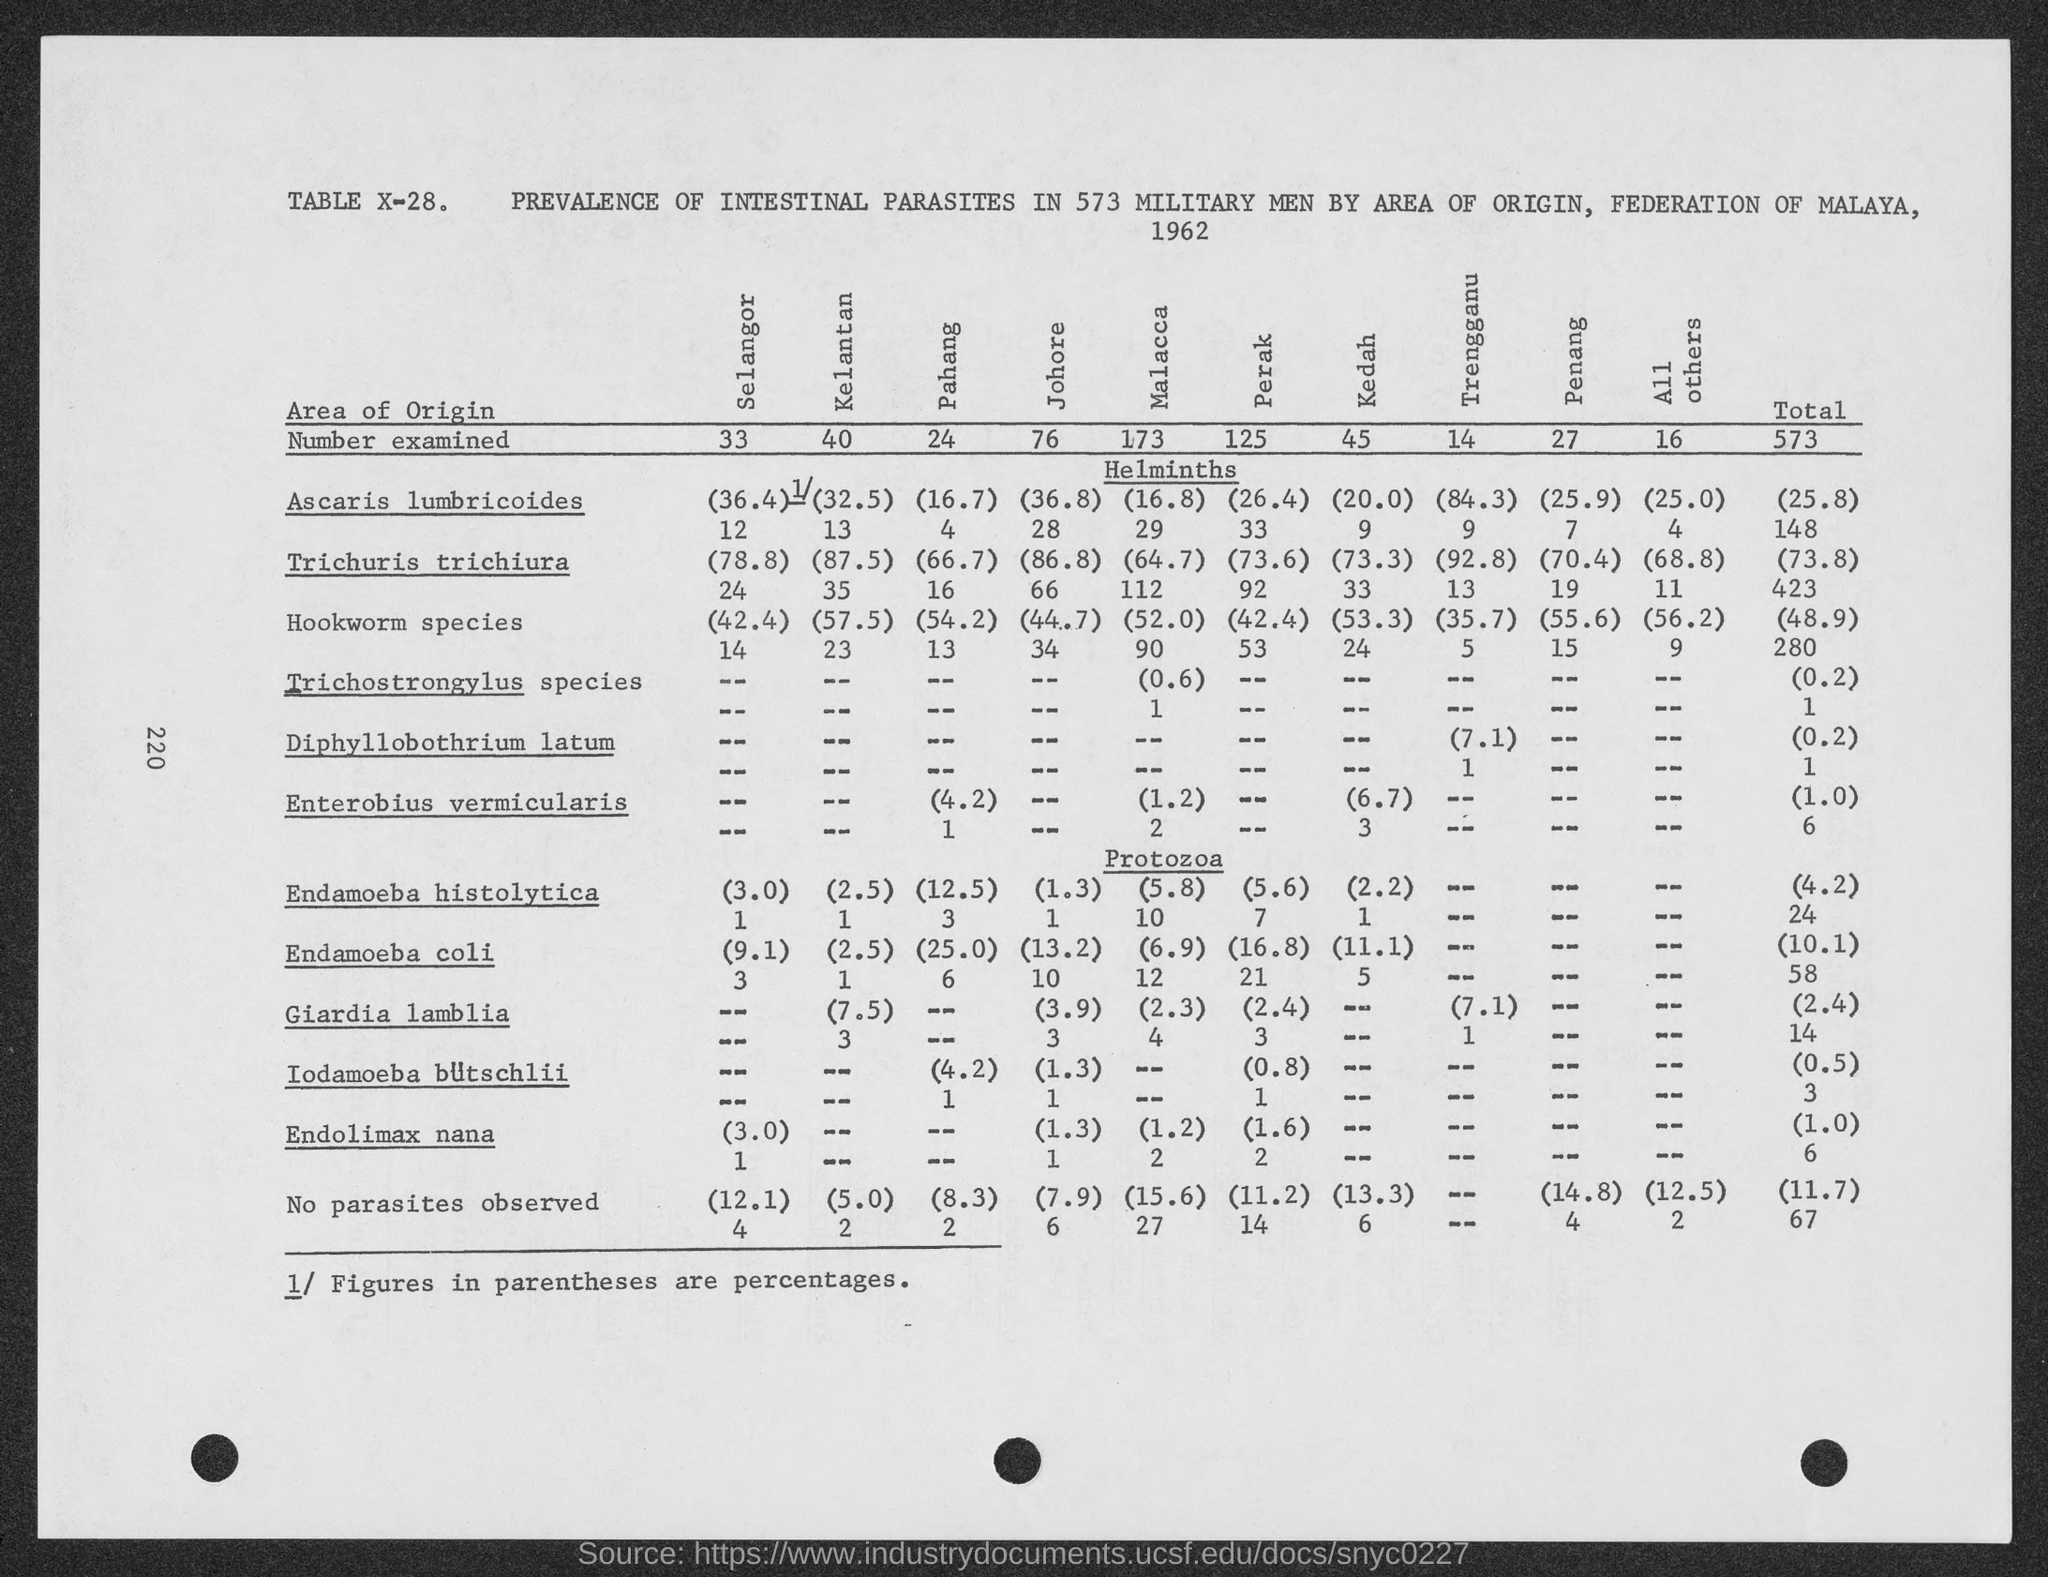What is the number examined in selangor ?
Keep it short and to the point. 33. What is the number examined in kelantan ?
Your answer should be very brief. 40. What is the number examined in pahang?
Keep it short and to the point. 24. What is the number examined in johore?
Ensure brevity in your answer.  76. What is the number examined in malacca ?
Make the answer very short. 173. What is the number examined in perak?
Your response must be concise. 125. What is the number examined in kedah?
Offer a very short reply. 45. What is the number examined in trengganu?
Ensure brevity in your answer.  14. What is the number examined in penang?
Offer a terse response. 27. What is the total number examined ?
Your answer should be compact. 573. 